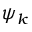Convert formula to latex. <formula><loc_0><loc_0><loc_500><loc_500>\psi _ { k }</formula> 